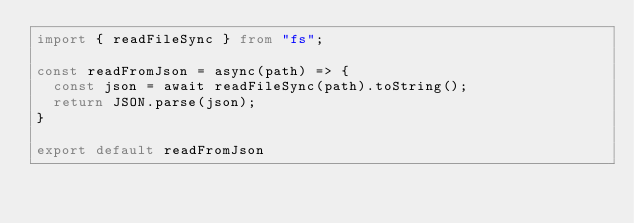<code> <loc_0><loc_0><loc_500><loc_500><_TypeScript_>import { readFileSync } from "fs";

const readFromJson = async(path) => {
  const json = await readFileSync(path).toString();
  return JSON.parse(json);
}

export default readFromJson</code> 